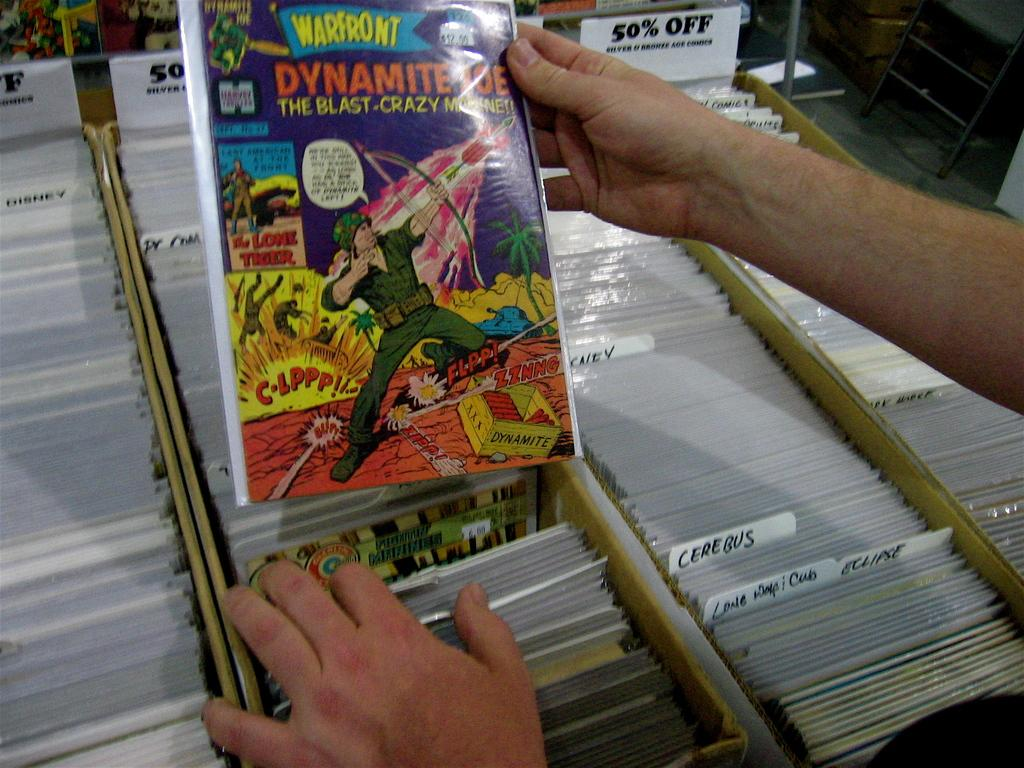Provide a one-sentence caption for the provided image. A man holds a Warfront comic above a box. 